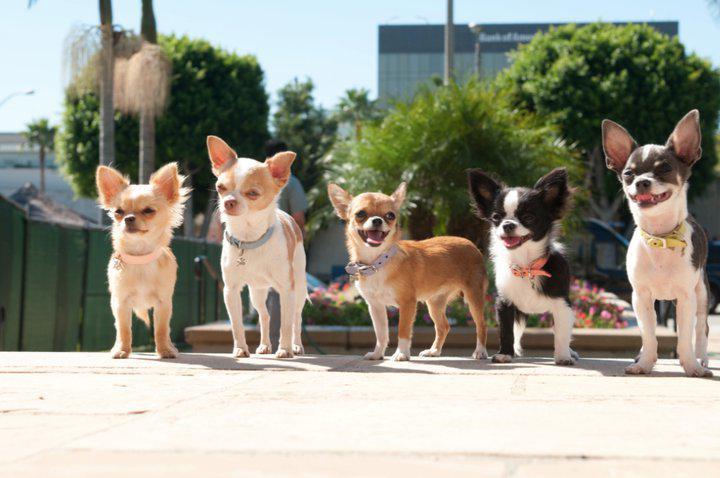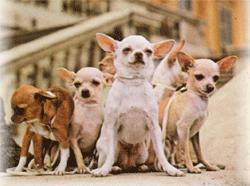The first image is the image on the left, the second image is the image on the right. Given the left and right images, does the statement "In one image, seven small dogs and a large gray and white cat are in a shady grassy yard area with trees and shrubs." hold true? Answer yes or no. No. The first image is the image on the left, the second image is the image on the right. Analyze the images presented: Is the assertion "The group of dogs in one of the images is standing on the grass." valid? Answer yes or no. No. 